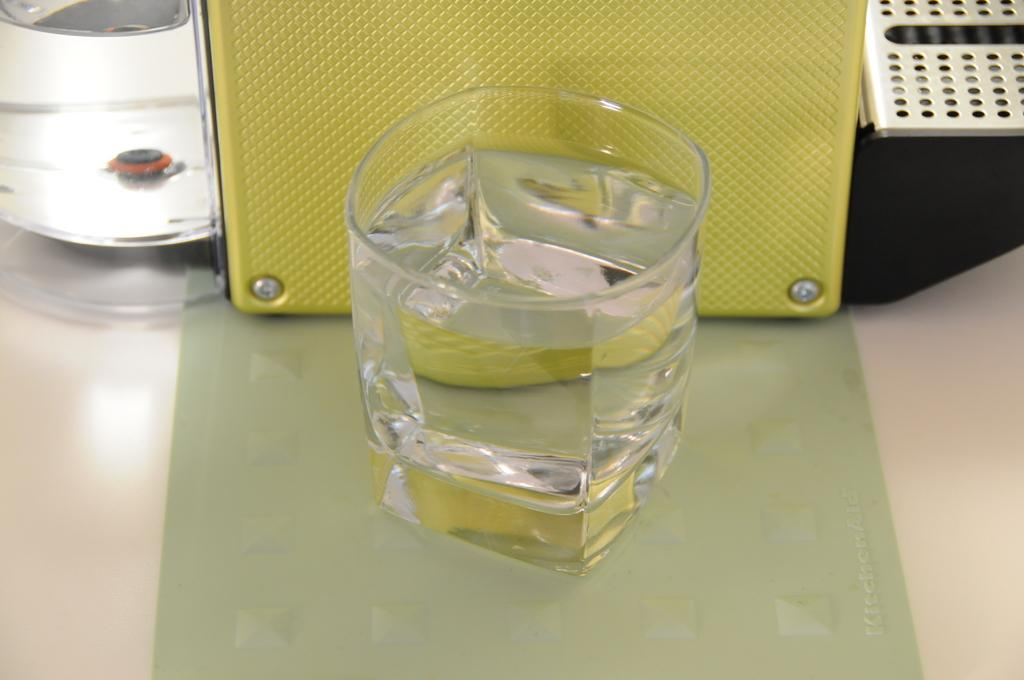What natural phenomenon is depicted in the image? There are water gales in the image. What objects can be seen on a table in the image? There are boxes on a table in the image. How many cows are present in the image? There are no cows present in the image. What is the cause of the water gales in the image? The cause of the water gales cannot be determined from the image alone. 